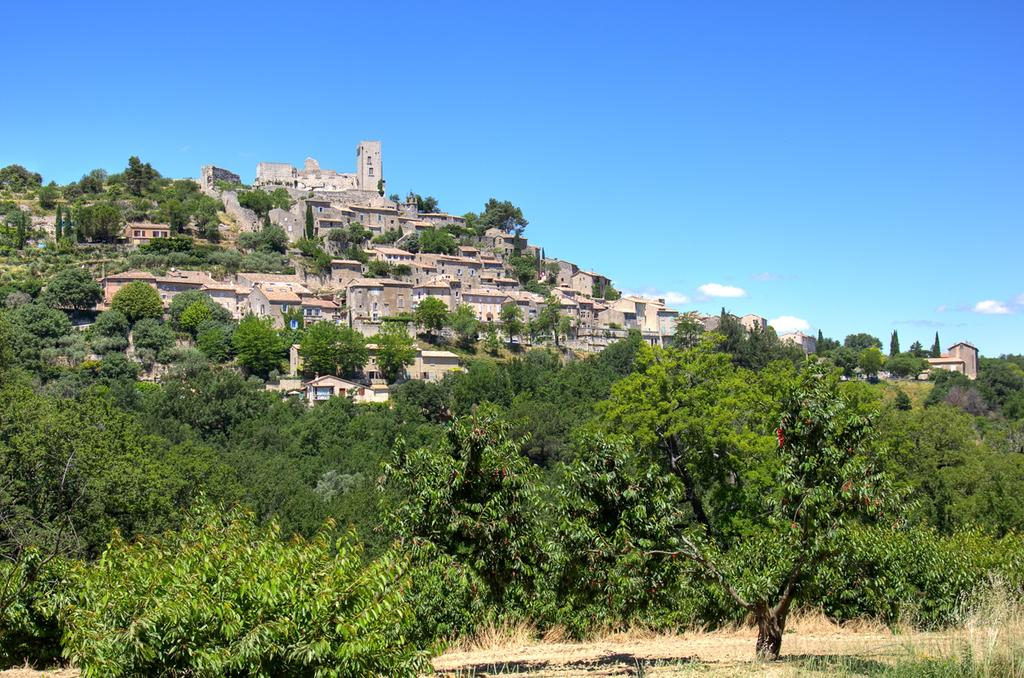What type of vegetation can be seen in the image? There are trees in the image. What type of structures are present in the image? There are buildings in the image. What is the color of the sky in the image? The sky is blue in color. What type of clouds can be seen in the image? There are no clouds visible in the image; only the blue sky is present. What letters are written on the buildings in the image? There are no letters visible on the buildings in the image; only the structures themselves are present. 